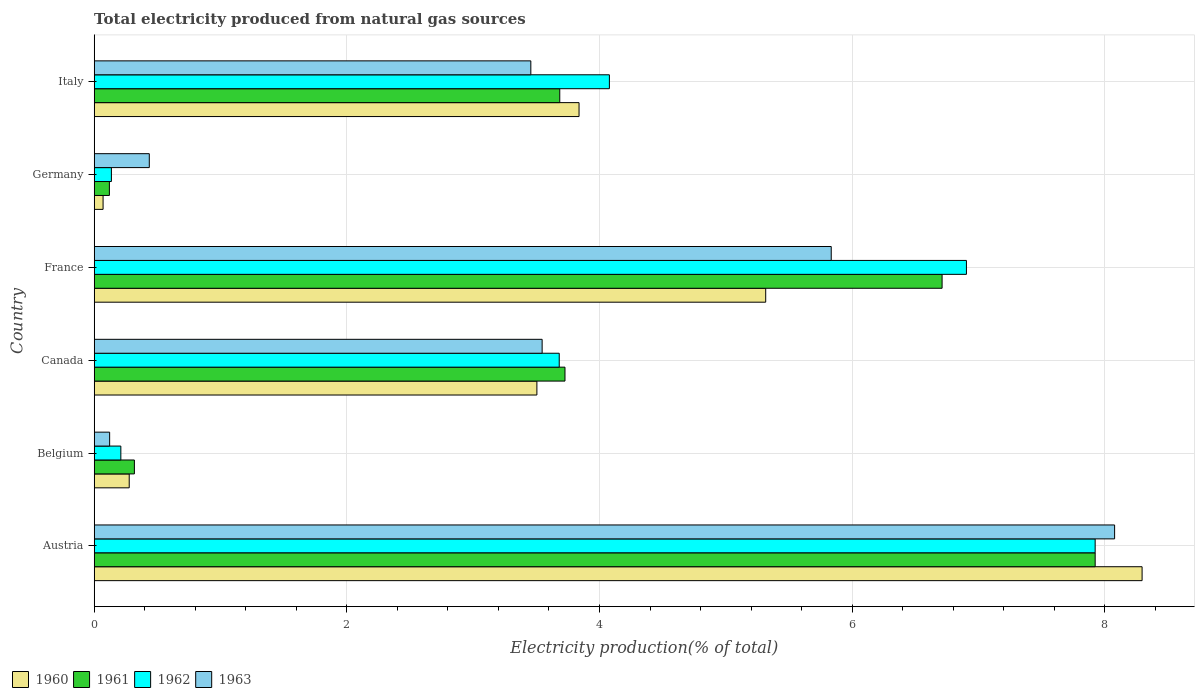How many groups of bars are there?
Your response must be concise. 6. Are the number of bars on each tick of the Y-axis equal?
Your response must be concise. Yes. How many bars are there on the 6th tick from the bottom?
Your answer should be compact. 4. What is the label of the 1st group of bars from the top?
Keep it short and to the point. Italy. What is the total electricity produced in 1961 in France?
Make the answer very short. 6.71. Across all countries, what is the maximum total electricity produced in 1962?
Your response must be concise. 7.92. Across all countries, what is the minimum total electricity produced in 1960?
Provide a short and direct response. 0.07. In which country was the total electricity produced in 1962 maximum?
Your response must be concise. Austria. In which country was the total electricity produced in 1960 minimum?
Make the answer very short. Germany. What is the total total electricity produced in 1963 in the graph?
Provide a succinct answer. 21.47. What is the difference between the total electricity produced in 1962 in Canada and that in Italy?
Keep it short and to the point. -0.4. What is the difference between the total electricity produced in 1962 in Italy and the total electricity produced in 1963 in Canada?
Make the answer very short. 0.53. What is the average total electricity produced in 1963 per country?
Your answer should be compact. 3.58. What is the difference between the total electricity produced in 1963 and total electricity produced in 1962 in Germany?
Provide a short and direct response. 0.3. What is the ratio of the total electricity produced in 1962 in France to that in Italy?
Make the answer very short. 1.69. Is the difference between the total electricity produced in 1963 in Canada and Italy greater than the difference between the total electricity produced in 1962 in Canada and Italy?
Keep it short and to the point. Yes. What is the difference between the highest and the second highest total electricity produced in 1962?
Offer a very short reply. 1.02. What is the difference between the highest and the lowest total electricity produced in 1961?
Offer a very short reply. 7.8. In how many countries, is the total electricity produced in 1962 greater than the average total electricity produced in 1962 taken over all countries?
Make the answer very short. 3. Is it the case that in every country, the sum of the total electricity produced in 1960 and total electricity produced in 1963 is greater than the sum of total electricity produced in 1962 and total electricity produced in 1961?
Your answer should be very brief. No. What does the 3rd bar from the top in France represents?
Your response must be concise. 1961. What does the 1st bar from the bottom in Germany represents?
Ensure brevity in your answer.  1960. Is it the case that in every country, the sum of the total electricity produced in 1963 and total electricity produced in 1961 is greater than the total electricity produced in 1962?
Give a very brief answer. Yes. How many bars are there?
Your response must be concise. 24. Are all the bars in the graph horizontal?
Make the answer very short. Yes. What is the difference between two consecutive major ticks on the X-axis?
Offer a very short reply. 2. Where does the legend appear in the graph?
Offer a terse response. Bottom left. How many legend labels are there?
Your answer should be very brief. 4. How are the legend labels stacked?
Ensure brevity in your answer.  Horizontal. What is the title of the graph?
Ensure brevity in your answer.  Total electricity produced from natural gas sources. Does "1965" appear as one of the legend labels in the graph?
Give a very brief answer. No. What is the label or title of the X-axis?
Ensure brevity in your answer.  Electricity production(% of total). What is the label or title of the Y-axis?
Keep it short and to the point. Country. What is the Electricity production(% of total) of 1960 in Austria?
Provide a short and direct response. 8.3. What is the Electricity production(% of total) of 1961 in Austria?
Provide a short and direct response. 7.92. What is the Electricity production(% of total) in 1962 in Austria?
Ensure brevity in your answer.  7.92. What is the Electricity production(% of total) of 1963 in Austria?
Provide a short and direct response. 8.08. What is the Electricity production(% of total) of 1960 in Belgium?
Your response must be concise. 0.28. What is the Electricity production(% of total) of 1961 in Belgium?
Your answer should be very brief. 0.32. What is the Electricity production(% of total) of 1962 in Belgium?
Ensure brevity in your answer.  0.21. What is the Electricity production(% of total) of 1963 in Belgium?
Provide a succinct answer. 0.12. What is the Electricity production(% of total) in 1960 in Canada?
Your answer should be compact. 3.5. What is the Electricity production(% of total) in 1961 in Canada?
Provide a succinct answer. 3.73. What is the Electricity production(% of total) in 1962 in Canada?
Offer a terse response. 3.68. What is the Electricity production(% of total) in 1963 in Canada?
Your response must be concise. 3.55. What is the Electricity production(% of total) in 1960 in France?
Keep it short and to the point. 5.32. What is the Electricity production(% of total) in 1961 in France?
Your response must be concise. 6.71. What is the Electricity production(% of total) of 1962 in France?
Offer a terse response. 6.91. What is the Electricity production(% of total) of 1963 in France?
Your response must be concise. 5.83. What is the Electricity production(% of total) of 1960 in Germany?
Your answer should be compact. 0.07. What is the Electricity production(% of total) in 1961 in Germany?
Your answer should be compact. 0.12. What is the Electricity production(% of total) of 1962 in Germany?
Give a very brief answer. 0.14. What is the Electricity production(% of total) in 1963 in Germany?
Make the answer very short. 0.44. What is the Electricity production(% of total) in 1960 in Italy?
Provide a short and direct response. 3.84. What is the Electricity production(% of total) of 1961 in Italy?
Keep it short and to the point. 3.69. What is the Electricity production(% of total) in 1962 in Italy?
Make the answer very short. 4.08. What is the Electricity production(% of total) in 1963 in Italy?
Your answer should be compact. 3.46. Across all countries, what is the maximum Electricity production(% of total) of 1960?
Make the answer very short. 8.3. Across all countries, what is the maximum Electricity production(% of total) of 1961?
Your response must be concise. 7.92. Across all countries, what is the maximum Electricity production(% of total) in 1962?
Your answer should be very brief. 7.92. Across all countries, what is the maximum Electricity production(% of total) of 1963?
Your answer should be very brief. 8.08. Across all countries, what is the minimum Electricity production(% of total) in 1960?
Your answer should be compact. 0.07. Across all countries, what is the minimum Electricity production(% of total) in 1961?
Provide a succinct answer. 0.12. Across all countries, what is the minimum Electricity production(% of total) in 1962?
Your response must be concise. 0.14. Across all countries, what is the minimum Electricity production(% of total) in 1963?
Your answer should be compact. 0.12. What is the total Electricity production(% of total) in 1960 in the graph?
Give a very brief answer. 21.3. What is the total Electricity production(% of total) of 1961 in the graph?
Make the answer very short. 22.49. What is the total Electricity production(% of total) of 1962 in the graph?
Ensure brevity in your answer.  22.94. What is the total Electricity production(% of total) of 1963 in the graph?
Make the answer very short. 21.47. What is the difference between the Electricity production(% of total) in 1960 in Austria and that in Belgium?
Offer a very short reply. 8.02. What is the difference between the Electricity production(% of total) in 1961 in Austria and that in Belgium?
Your answer should be compact. 7.61. What is the difference between the Electricity production(% of total) in 1962 in Austria and that in Belgium?
Provide a succinct answer. 7.71. What is the difference between the Electricity production(% of total) in 1963 in Austria and that in Belgium?
Make the answer very short. 7.96. What is the difference between the Electricity production(% of total) of 1960 in Austria and that in Canada?
Provide a succinct answer. 4.79. What is the difference between the Electricity production(% of total) of 1961 in Austria and that in Canada?
Make the answer very short. 4.2. What is the difference between the Electricity production(% of total) of 1962 in Austria and that in Canada?
Keep it short and to the point. 4.24. What is the difference between the Electricity production(% of total) in 1963 in Austria and that in Canada?
Offer a very short reply. 4.53. What is the difference between the Electricity production(% of total) of 1960 in Austria and that in France?
Your answer should be compact. 2.98. What is the difference between the Electricity production(% of total) in 1961 in Austria and that in France?
Offer a very short reply. 1.21. What is the difference between the Electricity production(% of total) of 1962 in Austria and that in France?
Make the answer very short. 1.02. What is the difference between the Electricity production(% of total) in 1963 in Austria and that in France?
Make the answer very short. 2.24. What is the difference between the Electricity production(% of total) in 1960 in Austria and that in Germany?
Give a very brief answer. 8.23. What is the difference between the Electricity production(% of total) in 1961 in Austria and that in Germany?
Offer a very short reply. 7.8. What is the difference between the Electricity production(% of total) in 1962 in Austria and that in Germany?
Your answer should be compact. 7.79. What is the difference between the Electricity production(% of total) in 1963 in Austria and that in Germany?
Offer a very short reply. 7.64. What is the difference between the Electricity production(% of total) in 1960 in Austria and that in Italy?
Offer a terse response. 4.46. What is the difference between the Electricity production(% of total) of 1961 in Austria and that in Italy?
Provide a succinct answer. 4.24. What is the difference between the Electricity production(% of total) of 1962 in Austria and that in Italy?
Ensure brevity in your answer.  3.85. What is the difference between the Electricity production(% of total) of 1963 in Austria and that in Italy?
Your answer should be very brief. 4.62. What is the difference between the Electricity production(% of total) of 1960 in Belgium and that in Canada?
Provide a succinct answer. -3.23. What is the difference between the Electricity production(% of total) of 1961 in Belgium and that in Canada?
Ensure brevity in your answer.  -3.41. What is the difference between the Electricity production(% of total) of 1962 in Belgium and that in Canada?
Keep it short and to the point. -3.47. What is the difference between the Electricity production(% of total) in 1963 in Belgium and that in Canada?
Your response must be concise. -3.42. What is the difference between the Electricity production(% of total) in 1960 in Belgium and that in France?
Ensure brevity in your answer.  -5.04. What is the difference between the Electricity production(% of total) in 1961 in Belgium and that in France?
Give a very brief answer. -6.39. What is the difference between the Electricity production(% of total) in 1962 in Belgium and that in France?
Your answer should be very brief. -6.69. What is the difference between the Electricity production(% of total) in 1963 in Belgium and that in France?
Your answer should be very brief. -5.71. What is the difference between the Electricity production(% of total) in 1960 in Belgium and that in Germany?
Provide a succinct answer. 0.21. What is the difference between the Electricity production(% of total) in 1961 in Belgium and that in Germany?
Your answer should be compact. 0.2. What is the difference between the Electricity production(% of total) in 1962 in Belgium and that in Germany?
Keep it short and to the point. 0.07. What is the difference between the Electricity production(% of total) in 1963 in Belgium and that in Germany?
Ensure brevity in your answer.  -0.31. What is the difference between the Electricity production(% of total) in 1960 in Belgium and that in Italy?
Offer a terse response. -3.56. What is the difference between the Electricity production(% of total) of 1961 in Belgium and that in Italy?
Make the answer very short. -3.37. What is the difference between the Electricity production(% of total) of 1962 in Belgium and that in Italy?
Your answer should be compact. -3.87. What is the difference between the Electricity production(% of total) of 1963 in Belgium and that in Italy?
Provide a short and direct response. -3.33. What is the difference between the Electricity production(% of total) in 1960 in Canada and that in France?
Offer a very short reply. -1.81. What is the difference between the Electricity production(% of total) of 1961 in Canada and that in France?
Offer a terse response. -2.99. What is the difference between the Electricity production(% of total) in 1962 in Canada and that in France?
Your answer should be very brief. -3.22. What is the difference between the Electricity production(% of total) of 1963 in Canada and that in France?
Offer a very short reply. -2.29. What is the difference between the Electricity production(% of total) in 1960 in Canada and that in Germany?
Keep it short and to the point. 3.43. What is the difference between the Electricity production(% of total) of 1961 in Canada and that in Germany?
Your answer should be compact. 3.61. What is the difference between the Electricity production(% of total) in 1962 in Canada and that in Germany?
Provide a short and direct response. 3.55. What is the difference between the Electricity production(% of total) of 1963 in Canada and that in Germany?
Your response must be concise. 3.11. What is the difference between the Electricity production(% of total) of 1960 in Canada and that in Italy?
Make the answer very short. -0.33. What is the difference between the Electricity production(% of total) of 1961 in Canada and that in Italy?
Ensure brevity in your answer.  0.04. What is the difference between the Electricity production(% of total) of 1962 in Canada and that in Italy?
Provide a short and direct response. -0.4. What is the difference between the Electricity production(% of total) of 1963 in Canada and that in Italy?
Offer a very short reply. 0.09. What is the difference between the Electricity production(% of total) in 1960 in France and that in Germany?
Offer a terse response. 5.25. What is the difference between the Electricity production(% of total) in 1961 in France and that in Germany?
Ensure brevity in your answer.  6.59. What is the difference between the Electricity production(% of total) of 1962 in France and that in Germany?
Your answer should be very brief. 6.77. What is the difference between the Electricity production(% of total) of 1963 in France and that in Germany?
Your answer should be very brief. 5.4. What is the difference between the Electricity production(% of total) of 1960 in France and that in Italy?
Ensure brevity in your answer.  1.48. What is the difference between the Electricity production(% of total) of 1961 in France and that in Italy?
Provide a succinct answer. 3.03. What is the difference between the Electricity production(% of total) in 1962 in France and that in Italy?
Keep it short and to the point. 2.83. What is the difference between the Electricity production(% of total) of 1963 in France and that in Italy?
Make the answer very short. 2.38. What is the difference between the Electricity production(% of total) of 1960 in Germany and that in Italy?
Ensure brevity in your answer.  -3.77. What is the difference between the Electricity production(% of total) of 1961 in Germany and that in Italy?
Your answer should be very brief. -3.57. What is the difference between the Electricity production(% of total) of 1962 in Germany and that in Italy?
Your response must be concise. -3.94. What is the difference between the Electricity production(% of total) in 1963 in Germany and that in Italy?
Your response must be concise. -3.02. What is the difference between the Electricity production(% of total) in 1960 in Austria and the Electricity production(% of total) in 1961 in Belgium?
Make the answer very short. 7.98. What is the difference between the Electricity production(% of total) of 1960 in Austria and the Electricity production(% of total) of 1962 in Belgium?
Provide a short and direct response. 8.08. What is the difference between the Electricity production(% of total) of 1960 in Austria and the Electricity production(% of total) of 1963 in Belgium?
Offer a terse response. 8.17. What is the difference between the Electricity production(% of total) in 1961 in Austria and the Electricity production(% of total) in 1962 in Belgium?
Your answer should be compact. 7.71. What is the difference between the Electricity production(% of total) in 1961 in Austria and the Electricity production(% of total) in 1963 in Belgium?
Make the answer very short. 7.8. What is the difference between the Electricity production(% of total) of 1962 in Austria and the Electricity production(% of total) of 1963 in Belgium?
Your response must be concise. 7.8. What is the difference between the Electricity production(% of total) of 1960 in Austria and the Electricity production(% of total) of 1961 in Canada?
Provide a short and direct response. 4.57. What is the difference between the Electricity production(% of total) in 1960 in Austria and the Electricity production(% of total) in 1962 in Canada?
Provide a succinct answer. 4.61. What is the difference between the Electricity production(% of total) in 1960 in Austria and the Electricity production(% of total) in 1963 in Canada?
Your answer should be compact. 4.75. What is the difference between the Electricity production(% of total) of 1961 in Austria and the Electricity production(% of total) of 1962 in Canada?
Provide a succinct answer. 4.24. What is the difference between the Electricity production(% of total) in 1961 in Austria and the Electricity production(% of total) in 1963 in Canada?
Make the answer very short. 4.38. What is the difference between the Electricity production(% of total) of 1962 in Austria and the Electricity production(% of total) of 1963 in Canada?
Your answer should be very brief. 4.38. What is the difference between the Electricity production(% of total) in 1960 in Austria and the Electricity production(% of total) in 1961 in France?
Provide a short and direct response. 1.58. What is the difference between the Electricity production(% of total) in 1960 in Austria and the Electricity production(% of total) in 1962 in France?
Ensure brevity in your answer.  1.39. What is the difference between the Electricity production(% of total) of 1960 in Austria and the Electricity production(% of total) of 1963 in France?
Keep it short and to the point. 2.46. What is the difference between the Electricity production(% of total) in 1961 in Austria and the Electricity production(% of total) in 1962 in France?
Your answer should be very brief. 1.02. What is the difference between the Electricity production(% of total) of 1961 in Austria and the Electricity production(% of total) of 1963 in France?
Make the answer very short. 2.09. What is the difference between the Electricity production(% of total) in 1962 in Austria and the Electricity production(% of total) in 1963 in France?
Offer a terse response. 2.09. What is the difference between the Electricity production(% of total) in 1960 in Austria and the Electricity production(% of total) in 1961 in Germany?
Make the answer very short. 8.18. What is the difference between the Electricity production(% of total) of 1960 in Austria and the Electricity production(% of total) of 1962 in Germany?
Give a very brief answer. 8.16. What is the difference between the Electricity production(% of total) in 1960 in Austria and the Electricity production(% of total) in 1963 in Germany?
Your response must be concise. 7.86. What is the difference between the Electricity production(% of total) in 1961 in Austria and the Electricity production(% of total) in 1962 in Germany?
Your response must be concise. 7.79. What is the difference between the Electricity production(% of total) of 1961 in Austria and the Electricity production(% of total) of 1963 in Germany?
Your response must be concise. 7.49. What is the difference between the Electricity production(% of total) in 1962 in Austria and the Electricity production(% of total) in 1963 in Germany?
Ensure brevity in your answer.  7.49. What is the difference between the Electricity production(% of total) in 1960 in Austria and the Electricity production(% of total) in 1961 in Italy?
Provide a short and direct response. 4.61. What is the difference between the Electricity production(% of total) in 1960 in Austria and the Electricity production(% of total) in 1962 in Italy?
Your response must be concise. 4.22. What is the difference between the Electricity production(% of total) of 1960 in Austria and the Electricity production(% of total) of 1963 in Italy?
Make the answer very short. 4.84. What is the difference between the Electricity production(% of total) of 1961 in Austria and the Electricity production(% of total) of 1962 in Italy?
Give a very brief answer. 3.85. What is the difference between the Electricity production(% of total) in 1961 in Austria and the Electricity production(% of total) in 1963 in Italy?
Keep it short and to the point. 4.47. What is the difference between the Electricity production(% of total) in 1962 in Austria and the Electricity production(% of total) in 1963 in Italy?
Keep it short and to the point. 4.47. What is the difference between the Electricity production(% of total) of 1960 in Belgium and the Electricity production(% of total) of 1961 in Canada?
Ensure brevity in your answer.  -3.45. What is the difference between the Electricity production(% of total) of 1960 in Belgium and the Electricity production(% of total) of 1962 in Canada?
Offer a very short reply. -3.4. What is the difference between the Electricity production(% of total) of 1960 in Belgium and the Electricity production(% of total) of 1963 in Canada?
Offer a terse response. -3.27. What is the difference between the Electricity production(% of total) in 1961 in Belgium and the Electricity production(% of total) in 1962 in Canada?
Offer a very short reply. -3.36. What is the difference between the Electricity production(% of total) in 1961 in Belgium and the Electricity production(% of total) in 1963 in Canada?
Provide a short and direct response. -3.23. What is the difference between the Electricity production(% of total) in 1962 in Belgium and the Electricity production(% of total) in 1963 in Canada?
Your response must be concise. -3.34. What is the difference between the Electricity production(% of total) in 1960 in Belgium and the Electricity production(% of total) in 1961 in France?
Your answer should be very brief. -6.43. What is the difference between the Electricity production(% of total) in 1960 in Belgium and the Electricity production(% of total) in 1962 in France?
Offer a very short reply. -6.63. What is the difference between the Electricity production(% of total) of 1960 in Belgium and the Electricity production(% of total) of 1963 in France?
Your answer should be very brief. -5.56. What is the difference between the Electricity production(% of total) in 1961 in Belgium and the Electricity production(% of total) in 1962 in France?
Make the answer very short. -6.59. What is the difference between the Electricity production(% of total) in 1961 in Belgium and the Electricity production(% of total) in 1963 in France?
Give a very brief answer. -5.52. What is the difference between the Electricity production(% of total) of 1962 in Belgium and the Electricity production(% of total) of 1963 in France?
Your answer should be compact. -5.62. What is the difference between the Electricity production(% of total) of 1960 in Belgium and the Electricity production(% of total) of 1961 in Germany?
Make the answer very short. 0.16. What is the difference between the Electricity production(% of total) in 1960 in Belgium and the Electricity production(% of total) in 1962 in Germany?
Provide a succinct answer. 0.14. What is the difference between the Electricity production(% of total) in 1960 in Belgium and the Electricity production(% of total) in 1963 in Germany?
Offer a terse response. -0.16. What is the difference between the Electricity production(% of total) in 1961 in Belgium and the Electricity production(% of total) in 1962 in Germany?
Offer a terse response. 0.18. What is the difference between the Electricity production(% of total) in 1961 in Belgium and the Electricity production(% of total) in 1963 in Germany?
Your answer should be compact. -0.12. What is the difference between the Electricity production(% of total) of 1962 in Belgium and the Electricity production(% of total) of 1963 in Germany?
Ensure brevity in your answer.  -0.23. What is the difference between the Electricity production(% of total) in 1960 in Belgium and the Electricity production(% of total) in 1961 in Italy?
Provide a short and direct response. -3.41. What is the difference between the Electricity production(% of total) in 1960 in Belgium and the Electricity production(% of total) in 1962 in Italy?
Give a very brief answer. -3.8. What is the difference between the Electricity production(% of total) in 1960 in Belgium and the Electricity production(% of total) in 1963 in Italy?
Your answer should be very brief. -3.18. What is the difference between the Electricity production(% of total) of 1961 in Belgium and the Electricity production(% of total) of 1962 in Italy?
Your answer should be compact. -3.76. What is the difference between the Electricity production(% of total) in 1961 in Belgium and the Electricity production(% of total) in 1963 in Italy?
Keep it short and to the point. -3.14. What is the difference between the Electricity production(% of total) of 1962 in Belgium and the Electricity production(% of total) of 1963 in Italy?
Your answer should be very brief. -3.25. What is the difference between the Electricity production(% of total) in 1960 in Canada and the Electricity production(% of total) in 1961 in France?
Provide a succinct answer. -3.21. What is the difference between the Electricity production(% of total) in 1960 in Canada and the Electricity production(% of total) in 1962 in France?
Offer a very short reply. -3.4. What is the difference between the Electricity production(% of total) in 1960 in Canada and the Electricity production(% of total) in 1963 in France?
Offer a very short reply. -2.33. What is the difference between the Electricity production(% of total) of 1961 in Canada and the Electricity production(% of total) of 1962 in France?
Your response must be concise. -3.18. What is the difference between the Electricity production(% of total) of 1961 in Canada and the Electricity production(% of total) of 1963 in France?
Offer a terse response. -2.11. What is the difference between the Electricity production(% of total) in 1962 in Canada and the Electricity production(% of total) in 1963 in France?
Give a very brief answer. -2.15. What is the difference between the Electricity production(% of total) of 1960 in Canada and the Electricity production(% of total) of 1961 in Germany?
Your answer should be compact. 3.38. What is the difference between the Electricity production(% of total) in 1960 in Canada and the Electricity production(% of total) in 1962 in Germany?
Give a very brief answer. 3.37. What is the difference between the Electricity production(% of total) in 1960 in Canada and the Electricity production(% of total) in 1963 in Germany?
Provide a short and direct response. 3.07. What is the difference between the Electricity production(% of total) in 1961 in Canada and the Electricity production(% of total) in 1962 in Germany?
Your answer should be very brief. 3.59. What is the difference between the Electricity production(% of total) in 1961 in Canada and the Electricity production(% of total) in 1963 in Germany?
Keep it short and to the point. 3.29. What is the difference between the Electricity production(% of total) of 1962 in Canada and the Electricity production(% of total) of 1963 in Germany?
Offer a very short reply. 3.25. What is the difference between the Electricity production(% of total) in 1960 in Canada and the Electricity production(% of total) in 1961 in Italy?
Give a very brief answer. -0.18. What is the difference between the Electricity production(% of total) of 1960 in Canada and the Electricity production(% of total) of 1962 in Italy?
Ensure brevity in your answer.  -0.57. What is the difference between the Electricity production(% of total) in 1960 in Canada and the Electricity production(% of total) in 1963 in Italy?
Make the answer very short. 0.05. What is the difference between the Electricity production(% of total) in 1961 in Canada and the Electricity production(% of total) in 1962 in Italy?
Your response must be concise. -0.35. What is the difference between the Electricity production(% of total) of 1961 in Canada and the Electricity production(% of total) of 1963 in Italy?
Make the answer very short. 0.27. What is the difference between the Electricity production(% of total) in 1962 in Canada and the Electricity production(% of total) in 1963 in Italy?
Give a very brief answer. 0.23. What is the difference between the Electricity production(% of total) of 1960 in France and the Electricity production(% of total) of 1961 in Germany?
Give a very brief answer. 5.2. What is the difference between the Electricity production(% of total) in 1960 in France and the Electricity production(% of total) in 1962 in Germany?
Ensure brevity in your answer.  5.18. What is the difference between the Electricity production(% of total) in 1960 in France and the Electricity production(% of total) in 1963 in Germany?
Your response must be concise. 4.88. What is the difference between the Electricity production(% of total) of 1961 in France and the Electricity production(% of total) of 1962 in Germany?
Your response must be concise. 6.58. What is the difference between the Electricity production(% of total) of 1961 in France and the Electricity production(% of total) of 1963 in Germany?
Offer a very short reply. 6.28. What is the difference between the Electricity production(% of total) of 1962 in France and the Electricity production(% of total) of 1963 in Germany?
Offer a terse response. 6.47. What is the difference between the Electricity production(% of total) in 1960 in France and the Electricity production(% of total) in 1961 in Italy?
Offer a very short reply. 1.63. What is the difference between the Electricity production(% of total) of 1960 in France and the Electricity production(% of total) of 1962 in Italy?
Provide a short and direct response. 1.24. What is the difference between the Electricity production(% of total) of 1960 in France and the Electricity production(% of total) of 1963 in Italy?
Offer a terse response. 1.86. What is the difference between the Electricity production(% of total) in 1961 in France and the Electricity production(% of total) in 1962 in Italy?
Provide a short and direct response. 2.63. What is the difference between the Electricity production(% of total) of 1961 in France and the Electricity production(% of total) of 1963 in Italy?
Provide a succinct answer. 3.26. What is the difference between the Electricity production(% of total) in 1962 in France and the Electricity production(% of total) in 1963 in Italy?
Give a very brief answer. 3.45. What is the difference between the Electricity production(% of total) in 1960 in Germany and the Electricity production(% of total) in 1961 in Italy?
Ensure brevity in your answer.  -3.62. What is the difference between the Electricity production(% of total) in 1960 in Germany and the Electricity production(% of total) in 1962 in Italy?
Offer a terse response. -4.01. What is the difference between the Electricity production(% of total) in 1960 in Germany and the Electricity production(% of total) in 1963 in Italy?
Your answer should be very brief. -3.39. What is the difference between the Electricity production(% of total) in 1961 in Germany and the Electricity production(% of total) in 1962 in Italy?
Provide a succinct answer. -3.96. What is the difference between the Electricity production(% of total) of 1961 in Germany and the Electricity production(% of total) of 1963 in Italy?
Offer a very short reply. -3.34. What is the difference between the Electricity production(% of total) in 1962 in Germany and the Electricity production(% of total) in 1963 in Italy?
Provide a succinct answer. -3.32. What is the average Electricity production(% of total) of 1960 per country?
Provide a succinct answer. 3.55. What is the average Electricity production(% of total) of 1961 per country?
Provide a short and direct response. 3.75. What is the average Electricity production(% of total) of 1962 per country?
Offer a terse response. 3.82. What is the average Electricity production(% of total) of 1963 per country?
Offer a terse response. 3.58. What is the difference between the Electricity production(% of total) in 1960 and Electricity production(% of total) in 1961 in Austria?
Your response must be concise. 0.37. What is the difference between the Electricity production(% of total) of 1960 and Electricity production(% of total) of 1962 in Austria?
Your response must be concise. 0.37. What is the difference between the Electricity production(% of total) in 1960 and Electricity production(% of total) in 1963 in Austria?
Keep it short and to the point. 0.22. What is the difference between the Electricity production(% of total) of 1961 and Electricity production(% of total) of 1962 in Austria?
Your answer should be compact. 0. What is the difference between the Electricity production(% of total) in 1961 and Electricity production(% of total) in 1963 in Austria?
Your response must be concise. -0.15. What is the difference between the Electricity production(% of total) in 1962 and Electricity production(% of total) in 1963 in Austria?
Your response must be concise. -0.15. What is the difference between the Electricity production(% of total) of 1960 and Electricity production(% of total) of 1961 in Belgium?
Offer a very short reply. -0.04. What is the difference between the Electricity production(% of total) in 1960 and Electricity production(% of total) in 1962 in Belgium?
Ensure brevity in your answer.  0.07. What is the difference between the Electricity production(% of total) in 1960 and Electricity production(% of total) in 1963 in Belgium?
Offer a very short reply. 0.15. What is the difference between the Electricity production(% of total) in 1961 and Electricity production(% of total) in 1962 in Belgium?
Your response must be concise. 0.11. What is the difference between the Electricity production(% of total) in 1961 and Electricity production(% of total) in 1963 in Belgium?
Your response must be concise. 0.2. What is the difference between the Electricity production(% of total) in 1962 and Electricity production(% of total) in 1963 in Belgium?
Your answer should be very brief. 0.09. What is the difference between the Electricity production(% of total) in 1960 and Electricity production(% of total) in 1961 in Canada?
Ensure brevity in your answer.  -0.22. What is the difference between the Electricity production(% of total) in 1960 and Electricity production(% of total) in 1962 in Canada?
Your answer should be very brief. -0.18. What is the difference between the Electricity production(% of total) of 1960 and Electricity production(% of total) of 1963 in Canada?
Your response must be concise. -0.04. What is the difference between the Electricity production(% of total) in 1961 and Electricity production(% of total) in 1962 in Canada?
Keep it short and to the point. 0.05. What is the difference between the Electricity production(% of total) in 1961 and Electricity production(% of total) in 1963 in Canada?
Offer a terse response. 0.18. What is the difference between the Electricity production(% of total) in 1962 and Electricity production(% of total) in 1963 in Canada?
Ensure brevity in your answer.  0.14. What is the difference between the Electricity production(% of total) in 1960 and Electricity production(% of total) in 1961 in France?
Keep it short and to the point. -1.4. What is the difference between the Electricity production(% of total) in 1960 and Electricity production(% of total) in 1962 in France?
Give a very brief answer. -1.59. What is the difference between the Electricity production(% of total) of 1960 and Electricity production(% of total) of 1963 in France?
Provide a succinct answer. -0.52. What is the difference between the Electricity production(% of total) of 1961 and Electricity production(% of total) of 1962 in France?
Offer a very short reply. -0.19. What is the difference between the Electricity production(% of total) in 1961 and Electricity production(% of total) in 1963 in France?
Keep it short and to the point. 0.88. What is the difference between the Electricity production(% of total) in 1962 and Electricity production(% of total) in 1963 in France?
Your answer should be compact. 1.07. What is the difference between the Electricity production(% of total) of 1960 and Electricity production(% of total) of 1961 in Germany?
Offer a terse response. -0.05. What is the difference between the Electricity production(% of total) of 1960 and Electricity production(% of total) of 1962 in Germany?
Make the answer very short. -0.07. What is the difference between the Electricity production(% of total) in 1960 and Electricity production(% of total) in 1963 in Germany?
Give a very brief answer. -0.37. What is the difference between the Electricity production(% of total) of 1961 and Electricity production(% of total) of 1962 in Germany?
Ensure brevity in your answer.  -0.02. What is the difference between the Electricity production(% of total) in 1961 and Electricity production(% of total) in 1963 in Germany?
Provide a short and direct response. -0.32. What is the difference between the Electricity production(% of total) in 1962 and Electricity production(% of total) in 1963 in Germany?
Give a very brief answer. -0.3. What is the difference between the Electricity production(% of total) of 1960 and Electricity production(% of total) of 1961 in Italy?
Offer a very short reply. 0.15. What is the difference between the Electricity production(% of total) of 1960 and Electricity production(% of total) of 1962 in Italy?
Keep it short and to the point. -0.24. What is the difference between the Electricity production(% of total) of 1960 and Electricity production(% of total) of 1963 in Italy?
Give a very brief answer. 0.38. What is the difference between the Electricity production(% of total) in 1961 and Electricity production(% of total) in 1962 in Italy?
Make the answer very short. -0.39. What is the difference between the Electricity production(% of total) of 1961 and Electricity production(% of total) of 1963 in Italy?
Give a very brief answer. 0.23. What is the difference between the Electricity production(% of total) of 1962 and Electricity production(% of total) of 1963 in Italy?
Give a very brief answer. 0.62. What is the ratio of the Electricity production(% of total) in 1960 in Austria to that in Belgium?
Your response must be concise. 29.93. What is the ratio of the Electricity production(% of total) in 1961 in Austria to that in Belgium?
Your answer should be compact. 24.9. What is the ratio of the Electricity production(% of total) of 1962 in Austria to that in Belgium?
Your answer should be very brief. 37.57. What is the ratio of the Electricity production(% of total) in 1963 in Austria to that in Belgium?
Your answer should be compact. 66.07. What is the ratio of the Electricity production(% of total) in 1960 in Austria to that in Canada?
Provide a short and direct response. 2.37. What is the ratio of the Electricity production(% of total) of 1961 in Austria to that in Canada?
Offer a very short reply. 2.13. What is the ratio of the Electricity production(% of total) in 1962 in Austria to that in Canada?
Provide a short and direct response. 2.15. What is the ratio of the Electricity production(% of total) of 1963 in Austria to that in Canada?
Your answer should be very brief. 2.28. What is the ratio of the Electricity production(% of total) of 1960 in Austria to that in France?
Your response must be concise. 1.56. What is the ratio of the Electricity production(% of total) in 1961 in Austria to that in France?
Make the answer very short. 1.18. What is the ratio of the Electricity production(% of total) of 1962 in Austria to that in France?
Your answer should be very brief. 1.15. What is the ratio of the Electricity production(% of total) of 1963 in Austria to that in France?
Keep it short and to the point. 1.38. What is the ratio of the Electricity production(% of total) in 1960 in Austria to that in Germany?
Give a very brief answer. 118.01. What is the ratio of the Electricity production(% of total) of 1961 in Austria to that in Germany?
Ensure brevity in your answer.  65.86. What is the ratio of the Electricity production(% of total) of 1962 in Austria to that in Germany?
Offer a very short reply. 58.17. What is the ratio of the Electricity production(% of total) of 1963 in Austria to that in Germany?
Provide a short and direct response. 18.52. What is the ratio of the Electricity production(% of total) in 1960 in Austria to that in Italy?
Provide a short and direct response. 2.16. What is the ratio of the Electricity production(% of total) in 1961 in Austria to that in Italy?
Make the answer very short. 2.15. What is the ratio of the Electricity production(% of total) of 1962 in Austria to that in Italy?
Make the answer very short. 1.94. What is the ratio of the Electricity production(% of total) in 1963 in Austria to that in Italy?
Ensure brevity in your answer.  2.34. What is the ratio of the Electricity production(% of total) of 1960 in Belgium to that in Canada?
Keep it short and to the point. 0.08. What is the ratio of the Electricity production(% of total) in 1961 in Belgium to that in Canada?
Provide a short and direct response. 0.09. What is the ratio of the Electricity production(% of total) of 1962 in Belgium to that in Canada?
Make the answer very short. 0.06. What is the ratio of the Electricity production(% of total) of 1963 in Belgium to that in Canada?
Give a very brief answer. 0.03. What is the ratio of the Electricity production(% of total) in 1960 in Belgium to that in France?
Your answer should be very brief. 0.05. What is the ratio of the Electricity production(% of total) in 1961 in Belgium to that in France?
Give a very brief answer. 0.05. What is the ratio of the Electricity production(% of total) in 1962 in Belgium to that in France?
Your answer should be compact. 0.03. What is the ratio of the Electricity production(% of total) in 1963 in Belgium to that in France?
Make the answer very short. 0.02. What is the ratio of the Electricity production(% of total) of 1960 in Belgium to that in Germany?
Provide a succinct answer. 3.94. What is the ratio of the Electricity production(% of total) in 1961 in Belgium to that in Germany?
Your answer should be very brief. 2.64. What is the ratio of the Electricity production(% of total) in 1962 in Belgium to that in Germany?
Ensure brevity in your answer.  1.55. What is the ratio of the Electricity production(% of total) in 1963 in Belgium to that in Germany?
Give a very brief answer. 0.28. What is the ratio of the Electricity production(% of total) in 1960 in Belgium to that in Italy?
Keep it short and to the point. 0.07. What is the ratio of the Electricity production(% of total) in 1961 in Belgium to that in Italy?
Provide a succinct answer. 0.09. What is the ratio of the Electricity production(% of total) in 1962 in Belgium to that in Italy?
Ensure brevity in your answer.  0.05. What is the ratio of the Electricity production(% of total) of 1963 in Belgium to that in Italy?
Your response must be concise. 0.04. What is the ratio of the Electricity production(% of total) in 1960 in Canada to that in France?
Keep it short and to the point. 0.66. What is the ratio of the Electricity production(% of total) of 1961 in Canada to that in France?
Offer a very short reply. 0.56. What is the ratio of the Electricity production(% of total) of 1962 in Canada to that in France?
Your response must be concise. 0.53. What is the ratio of the Electricity production(% of total) in 1963 in Canada to that in France?
Offer a very short reply. 0.61. What is the ratio of the Electricity production(% of total) in 1960 in Canada to that in Germany?
Keep it short and to the point. 49.85. What is the ratio of the Electricity production(% of total) of 1961 in Canada to that in Germany?
Ensure brevity in your answer.  30.98. What is the ratio of the Electricity production(% of total) in 1962 in Canada to that in Germany?
Make the answer very short. 27.02. What is the ratio of the Electricity production(% of total) in 1963 in Canada to that in Germany?
Keep it short and to the point. 8.13. What is the ratio of the Electricity production(% of total) of 1960 in Canada to that in Italy?
Ensure brevity in your answer.  0.91. What is the ratio of the Electricity production(% of total) in 1961 in Canada to that in Italy?
Ensure brevity in your answer.  1.01. What is the ratio of the Electricity production(% of total) of 1962 in Canada to that in Italy?
Your answer should be very brief. 0.9. What is the ratio of the Electricity production(% of total) of 1963 in Canada to that in Italy?
Make the answer very short. 1.03. What is the ratio of the Electricity production(% of total) of 1960 in France to that in Germany?
Make the answer very short. 75.62. What is the ratio of the Electricity production(% of total) of 1961 in France to that in Germany?
Make the answer very short. 55.79. What is the ratio of the Electricity production(% of total) of 1962 in France to that in Germany?
Make the answer very short. 50.69. What is the ratio of the Electricity production(% of total) of 1963 in France to that in Germany?
Your response must be concise. 13.38. What is the ratio of the Electricity production(% of total) in 1960 in France to that in Italy?
Your response must be concise. 1.39. What is the ratio of the Electricity production(% of total) in 1961 in France to that in Italy?
Offer a very short reply. 1.82. What is the ratio of the Electricity production(% of total) of 1962 in France to that in Italy?
Keep it short and to the point. 1.69. What is the ratio of the Electricity production(% of total) of 1963 in France to that in Italy?
Your answer should be very brief. 1.69. What is the ratio of the Electricity production(% of total) in 1960 in Germany to that in Italy?
Provide a short and direct response. 0.02. What is the ratio of the Electricity production(% of total) of 1961 in Germany to that in Italy?
Offer a very short reply. 0.03. What is the ratio of the Electricity production(% of total) of 1962 in Germany to that in Italy?
Ensure brevity in your answer.  0.03. What is the ratio of the Electricity production(% of total) of 1963 in Germany to that in Italy?
Give a very brief answer. 0.13. What is the difference between the highest and the second highest Electricity production(% of total) of 1960?
Ensure brevity in your answer.  2.98. What is the difference between the highest and the second highest Electricity production(% of total) in 1961?
Ensure brevity in your answer.  1.21. What is the difference between the highest and the second highest Electricity production(% of total) of 1963?
Make the answer very short. 2.24. What is the difference between the highest and the lowest Electricity production(% of total) of 1960?
Your answer should be very brief. 8.23. What is the difference between the highest and the lowest Electricity production(% of total) in 1961?
Your answer should be very brief. 7.8. What is the difference between the highest and the lowest Electricity production(% of total) in 1962?
Keep it short and to the point. 7.79. What is the difference between the highest and the lowest Electricity production(% of total) in 1963?
Give a very brief answer. 7.96. 